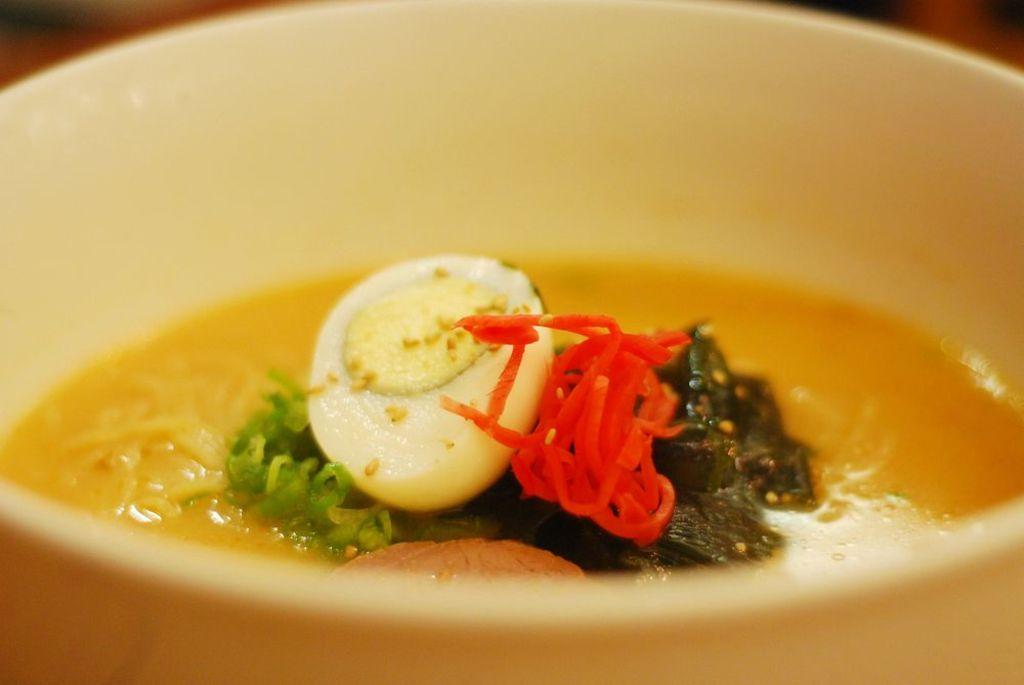In one or two sentences, can you explain what this image depicts? In this bowl I can see the soup, noodles, mint, tomato, pieces and boiled egg. This bowl is kept on the table. 